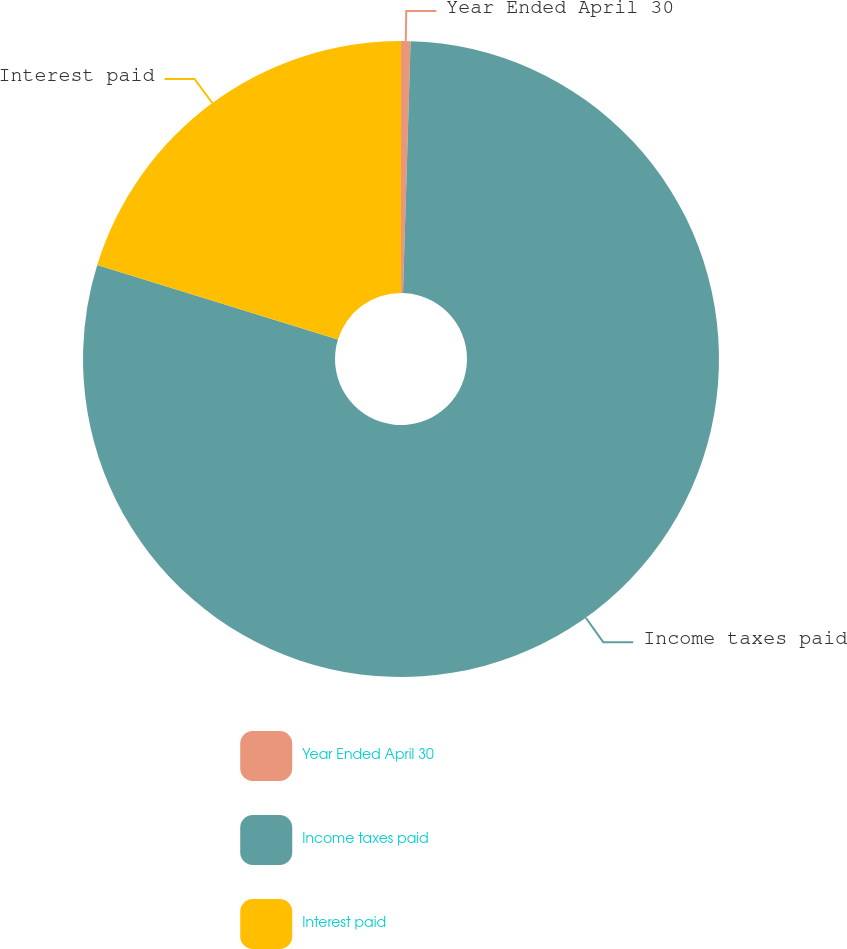Convert chart to OTSL. <chart><loc_0><loc_0><loc_500><loc_500><pie_chart><fcel>Year Ended April 30<fcel>Income taxes paid<fcel>Interest paid<nl><fcel>0.48%<fcel>79.3%<fcel>20.22%<nl></chart> 